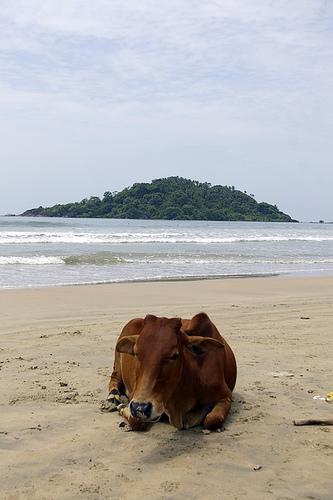Is this cow pretty?
Be succinct. Yes. What is the cow lying on?
Keep it brief. Sand. Is this creature usually seen on a beach?
Answer briefly. No. 